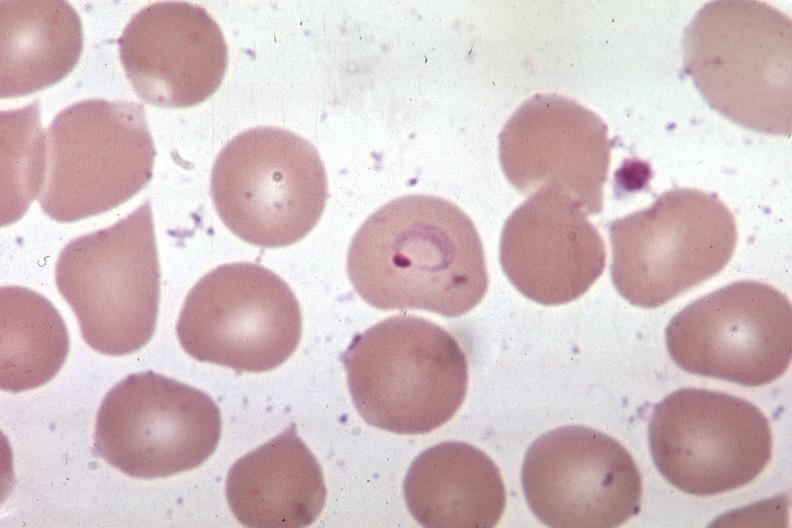s hematologic present?
Answer the question using a single word or phrase. Yes 